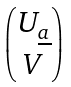<formula> <loc_0><loc_0><loc_500><loc_500>\begin{pmatrix} U _ { \underline { a } } \\ V \end{pmatrix}</formula> 